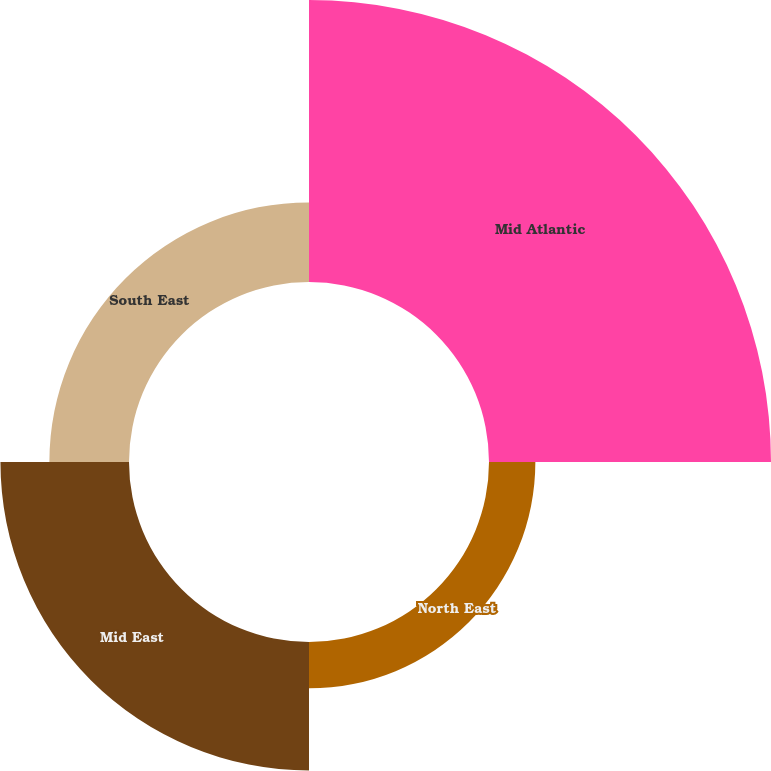Convert chart. <chart><loc_0><loc_0><loc_500><loc_500><pie_chart><fcel>Mid Atlantic<fcel>North East<fcel>Mid East<fcel>South East<nl><fcel>52.56%<fcel>8.64%<fcel>23.96%<fcel>14.84%<nl></chart> 